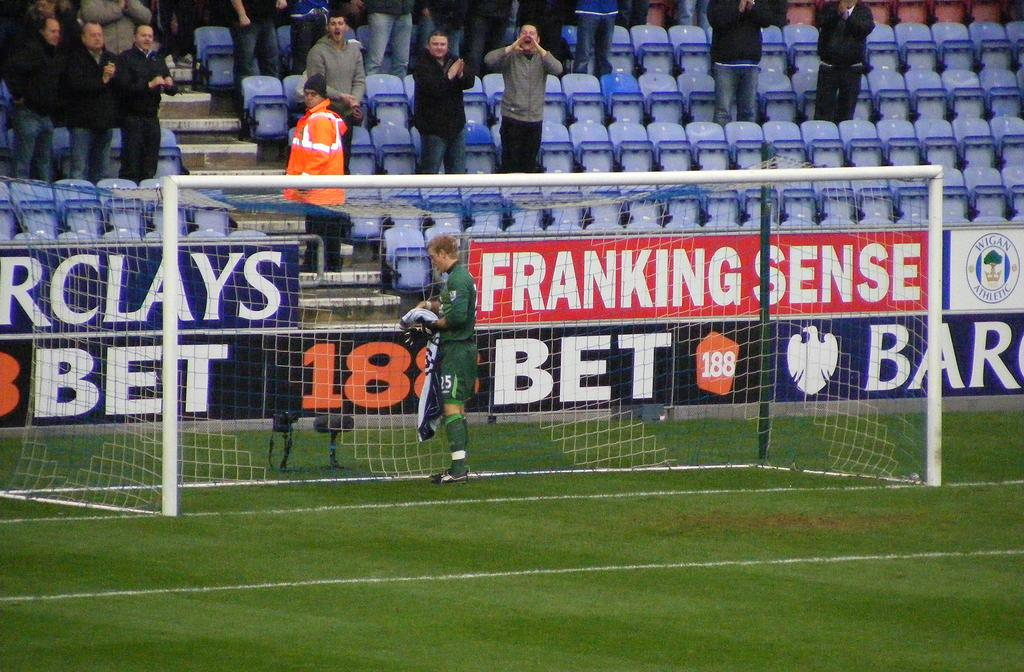<image>
Present a compact description of the photo's key features. Franking Sense is a sponsor for this soccer field. 